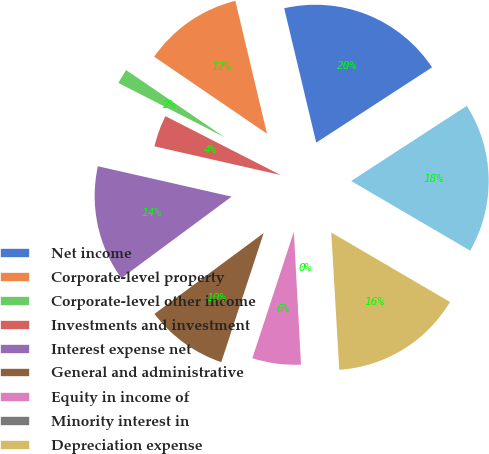Convert chart. <chart><loc_0><loc_0><loc_500><loc_500><pie_chart><fcel>Net income<fcel>Corporate-level property<fcel>Corporate-level other income<fcel>Investments and investment<fcel>Interest expense net<fcel>General and administrative<fcel>Equity in income of<fcel>Minority interest in<fcel>Depreciation expense<fcel>Gain on sale of real estate<nl><fcel>19.55%<fcel>11.75%<fcel>2.01%<fcel>3.96%<fcel>13.7%<fcel>9.81%<fcel>5.91%<fcel>0.07%<fcel>15.65%<fcel>17.6%<nl></chart> 